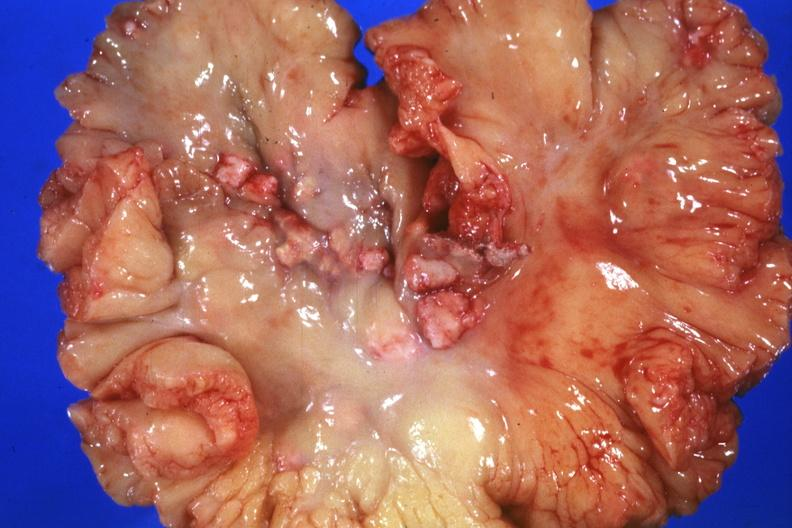what is present?
Answer the question using a single word or phrase. Lymph node 